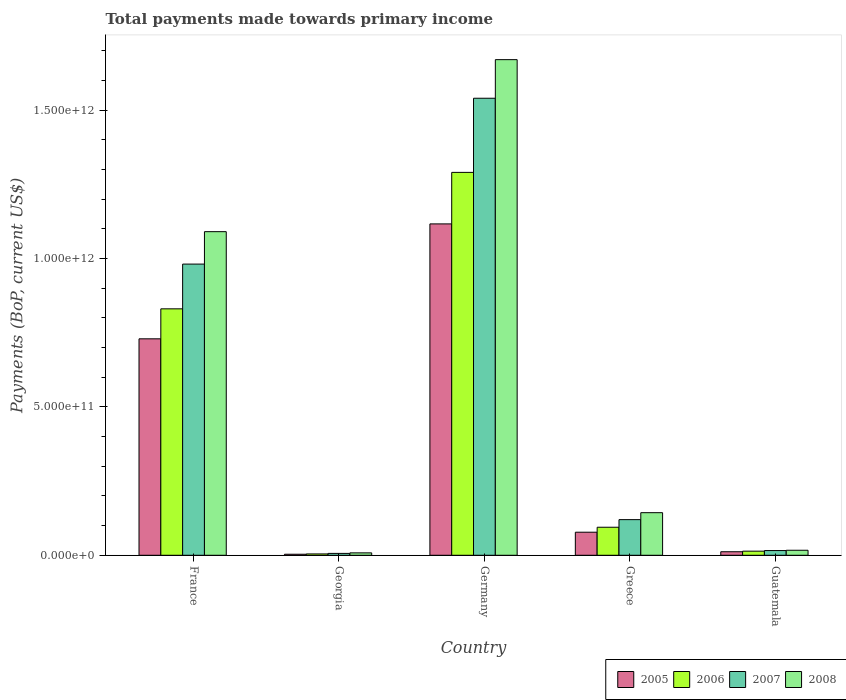How many different coloured bars are there?
Make the answer very short. 4. How many bars are there on the 3rd tick from the right?
Provide a succinct answer. 4. What is the label of the 3rd group of bars from the left?
Offer a very short reply. Germany. In how many cases, is the number of bars for a given country not equal to the number of legend labels?
Offer a very short reply. 0. What is the total payments made towards primary income in 2007 in Guatemala?
Provide a succinct answer. 1.59e+1. Across all countries, what is the maximum total payments made towards primary income in 2008?
Your answer should be compact. 1.67e+12. Across all countries, what is the minimum total payments made towards primary income in 2008?
Offer a terse response. 8.11e+09. In which country was the total payments made towards primary income in 2006 minimum?
Give a very brief answer. Georgia. What is the total total payments made towards primary income in 2006 in the graph?
Make the answer very short. 2.23e+12. What is the difference between the total payments made towards primary income in 2005 in France and that in Greece?
Provide a short and direct response. 6.52e+11. What is the difference between the total payments made towards primary income in 2005 in Georgia and the total payments made towards primary income in 2006 in Germany?
Ensure brevity in your answer.  -1.29e+12. What is the average total payments made towards primary income in 2005 per country?
Provide a short and direct response. 3.88e+11. What is the difference between the total payments made towards primary income of/in 2008 and total payments made towards primary income of/in 2005 in Germany?
Your answer should be compact. 5.53e+11. In how many countries, is the total payments made towards primary income in 2005 greater than 1300000000000 US$?
Your answer should be compact. 0. What is the ratio of the total payments made towards primary income in 2005 in Germany to that in Greece?
Your answer should be compact. 14.37. Is the difference between the total payments made towards primary income in 2008 in Georgia and Germany greater than the difference between the total payments made towards primary income in 2005 in Georgia and Germany?
Offer a very short reply. No. What is the difference between the highest and the second highest total payments made towards primary income in 2007?
Offer a terse response. 1.42e+12. What is the difference between the highest and the lowest total payments made towards primary income in 2007?
Give a very brief answer. 1.53e+12. What does the 2nd bar from the right in France represents?
Your answer should be very brief. 2007. How many bars are there?
Your answer should be compact. 20. How many countries are there in the graph?
Provide a succinct answer. 5. What is the difference between two consecutive major ticks on the Y-axis?
Your response must be concise. 5.00e+11. Does the graph contain any zero values?
Provide a short and direct response. No. How many legend labels are there?
Keep it short and to the point. 4. What is the title of the graph?
Your answer should be very brief. Total payments made towards primary income. What is the label or title of the Y-axis?
Ensure brevity in your answer.  Payments (BoP, current US$). What is the Payments (BoP, current US$) of 2005 in France?
Keep it short and to the point. 7.29e+11. What is the Payments (BoP, current US$) of 2006 in France?
Provide a succinct answer. 8.30e+11. What is the Payments (BoP, current US$) in 2007 in France?
Your answer should be very brief. 9.81e+11. What is the Payments (BoP, current US$) in 2008 in France?
Offer a very short reply. 1.09e+12. What is the Payments (BoP, current US$) of 2005 in Georgia?
Your response must be concise. 3.47e+09. What is the Payments (BoP, current US$) in 2006 in Georgia?
Your response must be concise. 4.56e+09. What is the Payments (BoP, current US$) of 2007 in Georgia?
Ensure brevity in your answer.  6.32e+09. What is the Payments (BoP, current US$) in 2008 in Georgia?
Your answer should be compact. 8.11e+09. What is the Payments (BoP, current US$) of 2005 in Germany?
Ensure brevity in your answer.  1.12e+12. What is the Payments (BoP, current US$) in 2006 in Germany?
Ensure brevity in your answer.  1.29e+12. What is the Payments (BoP, current US$) of 2007 in Germany?
Offer a very short reply. 1.54e+12. What is the Payments (BoP, current US$) in 2008 in Germany?
Provide a succinct answer. 1.67e+12. What is the Payments (BoP, current US$) of 2005 in Greece?
Offer a terse response. 7.77e+1. What is the Payments (BoP, current US$) of 2006 in Greece?
Keep it short and to the point. 9.44e+1. What is the Payments (BoP, current US$) in 2007 in Greece?
Provide a short and direct response. 1.20e+11. What is the Payments (BoP, current US$) in 2008 in Greece?
Your answer should be compact. 1.44e+11. What is the Payments (BoP, current US$) of 2005 in Guatemala?
Your response must be concise. 1.19e+1. What is the Payments (BoP, current US$) in 2006 in Guatemala?
Provide a short and direct response. 1.38e+1. What is the Payments (BoP, current US$) in 2007 in Guatemala?
Your answer should be very brief. 1.59e+1. What is the Payments (BoP, current US$) in 2008 in Guatemala?
Provide a short and direct response. 1.69e+1. Across all countries, what is the maximum Payments (BoP, current US$) of 2005?
Provide a succinct answer. 1.12e+12. Across all countries, what is the maximum Payments (BoP, current US$) in 2006?
Make the answer very short. 1.29e+12. Across all countries, what is the maximum Payments (BoP, current US$) in 2007?
Provide a succinct answer. 1.54e+12. Across all countries, what is the maximum Payments (BoP, current US$) in 2008?
Give a very brief answer. 1.67e+12. Across all countries, what is the minimum Payments (BoP, current US$) in 2005?
Keep it short and to the point. 3.47e+09. Across all countries, what is the minimum Payments (BoP, current US$) of 2006?
Ensure brevity in your answer.  4.56e+09. Across all countries, what is the minimum Payments (BoP, current US$) of 2007?
Keep it short and to the point. 6.32e+09. Across all countries, what is the minimum Payments (BoP, current US$) of 2008?
Provide a succinct answer. 8.11e+09. What is the total Payments (BoP, current US$) in 2005 in the graph?
Provide a succinct answer. 1.94e+12. What is the total Payments (BoP, current US$) of 2006 in the graph?
Make the answer very short. 2.23e+12. What is the total Payments (BoP, current US$) in 2007 in the graph?
Give a very brief answer. 2.66e+12. What is the total Payments (BoP, current US$) of 2008 in the graph?
Keep it short and to the point. 2.93e+12. What is the difference between the Payments (BoP, current US$) of 2005 in France and that in Georgia?
Your response must be concise. 7.26e+11. What is the difference between the Payments (BoP, current US$) in 2006 in France and that in Georgia?
Provide a short and direct response. 8.26e+11. What is the difference between the Payments (BoP, current US$) of 2007 in France and that in Georgia?
Your response must be concise. 9.75e+11. What is the difference between the Payments (BoP, current US$) in 2008 in France and that in Georgia?
Give a very brief answer. 1.08e+12. What is the difference between the Payments (BoP, current US$) in 2005 in France and that in Germany?
Your answer should be very brief. -3.87e+11. What is the difference between the Payments (BoP, current US$) in 2006 in France and that in Germany?
Your answer should be compact. -4.60e+11. What is the difference between the Payments (BoP, current US$) in 2007 in France and that in Germany?
Your answer should be compact. -5.59e+11. What is the difference between the Payments (BoP, current US$) in 2008 in France and that in Germany?
Your answer should be compact. -5.80e+11. What is the difference between the Payments (BoP, current US$) of 2005 in France and that in Greece?
Your answer should be very brief. 6.52e+11. What is the difference between the Payments (BoP, current US$) in 2006 in France and that in Greece?
Make the answer very short. 7.36e+11. What is the difference between the Payments (BoP, current US$) in 2007 in France and that in Greece?
Ensure brevity in your answer.  8.61e+11. What is the difference between the Payments (BoP, current US$) in 2008 in France and that in Greece?
Your answer should be compact. 9.47e+11. What is the difference between the Payments (BoP, current US$) in 2005 in France and that in Guatemala?
Provide a succinct answer. 7.17e+11. What is the difference between the Payments (BoP, current US$) in 2006 in France and that in Guatemala?
Offer a terse response. 8.17e+11. What is the difference between the Payments (BoP, current US$) of 2007 in France and that in Guatemala?
Ensure brevity in your answer.  9.65e+11. What is the difference between the Payments (BoP, current US$) in 2008 in France and that in Guatemala?
Your answer should be very brief. 1.07e+12. What is the difference between the Payments (BoP, current US$) of 2005 in Georgia and that in Germany?
Offer a terse response. -1.11e+12. What is the difference between the Payments (BoP, current US$) in 2006 in Georgia and that in Germany?
Keep it short and to the point. -1.29e+12. What is the difference between the Payments (BoP, current US$) in 2007 in Georgia and that in Germany?
Ensure brevity in your answer.  -1.53e+12. What is the difference between the Payments (BoP, current US$) of 2008 in Georgia and that in Germany?
Your answer should be compact. -1.66e+12. What is the difference between the Payments (BoP, current US$) of 2005 in Georgia and that in Greece?
Offer a terse response. -7.43e+1. What is the difference between the Payments (BoP, current US$) of 2006 in Georgia and that in Greece?
Provide a succinct answer. -8.99e+1. What is the difference between the Payments (BoP, current US$) in 2007 in Georgia and that in Greece?
Keep it short and to the point. -1.14e+11. What is the difference between the Payments (BoP, current US$) of 2008 in Georgia and that in Greece?
Your answer should be compact. -1.35e+11. What is the difference between the Payments (BoP, current US$) of 2005 in Georgia and that in Guatemala?
Provide a short and direct response. -8.42e+09. What is the difference between the Payments (BoP, current US$) in 2006 in Georgia and that in Guatemala?
Your answer should be very brief. -9.27e+09. What is the difference between the Payments (BoP, current US$) in 2007 in Georgia and that in Guatemala?
Offer a very short reply. -9.59e+09. What is the difference between the Payments (BoP, current US$) of 2008 in Georgia and that in Guatemala?
Your answer should be compact. -8.77e+09. What is the difference between the Payments (BoP, current US$) in 2005 in Germany and that in Greece?
Offer a very short reply. 1.04e+12. What is the difference between the Payments (BoP, current US$) in 2006 in Germany and that in Greece?
Keep it short and to the point. 1.20e+12. What is the difference between the Payments (BoP, current US$) in 2007 in Germany and that in Greece?
Offer a very short reply. 1.42e+12. What is the difference between the Payments (BoP, current US$) in 2008 in Germany and that in Greece?
Give a very brief answer. 1.53e+12. What is the difference between the Payments (BoP, current US$) of 2005 in Germany and that in Guatemala?
Make the answer very short. 1.10e+12. What is the difference between the Payments (BoP, current US$) in 2006 in Germany and that in Guatemala?
Make the answer very short. 1.28e+12. What is the difference between the Payments (BoP, current US$) in 2007 in Germany and that in Guatemala?
Your answer should be compact. 1.52e+12. What is the difference between the Payments (BoP, current US$) of 2008 in Germany and that in Guatemala?
Make the answer very short. 1.65e+12. What is the difference between the Payments (BoP, current US$) of 2005 in Greece and that in Guatemala?
Give a very brief answer. 6.58e+1. What is the difference between the Payments (BoP, current US$) in 2006 in Greece and that in Guatemala?
Provide a short and direct response. 8.06e+1. What is the difference between the Payments (BoP, current US$) of 2007 in Greece and that in Guatemala?
Provide a short and direct response. 1.04e+11. What is the difference between the Payments (BoP, current US$) in 2008 in Greece and that in Guatemala?
Provide a short and direct response. 1.27e+11. What is the difference between the Payments (BoP, current US$) in 2005 in France and the Payments (BoP, current US$) in 2006 in Georgia?
Keep it short and to the point. 7.25e+11. What is the difference between the Payments (BoP, current US$) in 2005 in France and the Payments (BoP, current US$) in 2007 in Georgia?
Give a very brief answer. 7.23e+11. What is the difference between the Payments (BoP, current US$) of 2005 in France and the Payments (BoP, current US$) of 2008 in Georgia?
Offer a terse response. 7.21e+11. What is the difference between the Payments (BoP, current US$) in 2006 in France and the Payments (BoP, current US$) in 2007 in Georgia?
Offer a terse response. 8.24e+11. What is the difference between the Payments (BoP, current US$) of 2006 in France and the Payments (BoP, current US$) of 2008 in Georgia?
Offer a very short reply. 8.22e+11. What is the difference between the Payments (BoP, current US$) of 2007 in France and the Payments (BoP, current US$) of 2008 in Georgia?
Your response must be concise. 9.73e+11. What is the difference between the Payments (BoP, current US$) in 2005 in France and the Payments (BoP, current US$) in 2006 in Germany?
Ensure brevity in your answer.  -5.61e+11. What is the difference between the Payments (BoP, current US$) in 2005 in France and the Payments (BoP, current US$) in 2007 in Germany?
Provide a succinct answer. -8.11e+11. What is the difference between the Payments (BoP, current US$) of 2005 in France and the Payments (BoP, current US$) of 2008 in Germany?
Your answer should be very brief. -9.41e+11. What is the difference between the Payments (BoP, current US$) of 2006 in France and the Payments (BoP, current US$) of 2007 in Germany?
Your answer should be very brief. -7.10e+11. What is the difference between the Payments (BoP, current US$) in 2006 in France and the Payments (BoP, current US$) in 2008 in Germany?
Offer a very short reply. -8.40e+11. What is the difference between the Payments (BoP, current US$) of 2007 in France and the Payments (BoP, current US$) of 2008 in Germany?
Your answer should be compact. -6.89e+11. What is the difference between the Payments (BoP, current US$) of 2005 in France and the Payments (BoP, current US$) of 2006 in Greece?
Your answer should be very brief. 6.35e+11. What is the difference between the Payments (BoP, current US$) in 2005 in France and the Payments (BoP, current US$) in 2007 in Greece?
Your answer should be compact. 6.09e+11. What is the difference between the Payments (BoP, current US$) of 2005 in France and the Payments (BoP, current US$) of 2008 in Greece?
Your response must be concise. 5.86e+11. What is the difference between the Payments (BoP, current US$) in 2006 in France and the Payments (BoP, current US$) in 2007 in Greece?
Make the answer very short. 7.10e+11. What is the difference between the Payments (BoP, current US$) of 2006 in France and the Payments (BoP, current US$) of 2008 in Greece?
Your response must be concise. 6.87e+11. What is the difference between the Payments (BoP, current US$) of 2007 in France and the Payments (BoP, current US$) of 2008 in Greece?
Your response must be concise. 8.38e+11. What is the difference between the Payments (BoP, current US$) of 2005 in France and the Payments (BoP, current US$) of 2006 in Guatemala?
Provide a short and direct response. 7.15e+11. What is the difference between the Payments (BoP, current US$) in 2005 in France and the Payments (BoP, current US$) in 2007 in Guatemala?
Provide a short and direct response. 7.13e+11. What is the difference between the Payments (BoP, current US$) in 2005 in France and the Payments (BoP, current US$) in 2008 in Guatemala?
Provide a succinct answer. 7.12e+11. What is the difference between the Payments (BoP, current US$) of 2006 in France and the Payments (BoP, current US$) of 2007 in Guatemala?
Give a very brief answer. 8.14e+11. What is the difference between the Payments (BoP, current US$) in 2006 in France and the Payments (BoP, current US$) in 2008 in Guatemala?
Offer a very short reply. 8.13e+11. What is the difference between the Payments (BoP, current US$) in 2007 in France and the Payments (BoP, current US$) in 2008 in Guatemala?
Make the answer very short. 9.64e+11. What is the difference between the Payments (BoP, current US$) in 2005 in Georgia and the Payments (BoP, current US$) in 2006 in Germany?
Your response must be concise. -1.29e+12. What is the difference between the Payments (BoP, current US$) of 2005 in Georgia and the Payments (BoP, current US$) of 2007 in Germany?
Ensure brevity in your answer.  -1.54e+12. What is the difference between the Payments (BoP, current US$) of 2005 in Georgia and the Payments (BoP, current US$) of 2008 in Germany?
Keep it short and to the point. -1.67e+12. What is the difference between the Payments (BoP, current US$) of 2006 in Georgia and the Payments (BoP, current US$) of 2007 in Germany?
Make the answer very short. -1.54e+12. What is the difference between the Payments (BoP, current US$) in 2006 in Georgia and the Payments (BoP, current US$) in 2008 in Germany?
Provide a short and direct response. -1.67e+12. What is the difference between the Payments (BoP, current US$) of 2007 in Georgia and the Payments (BoP, current US$) of 2008 in Germany?
Your response must be concise. -1.66e+12. What is the difference between the Payments (BoP, current US$) of 2005 in Georgia and the Payments (BoP, current US$) of 2006 in Greece?
Your answer should be very brief. -9.10e+1. What is the difference between the Payments (BoP, current US$) of 2005 in Georgia and the Payments (BoP, current US$) of 2007 in Greece?
Your response must be concise. -1.17e+11. What is the difference between the Payments (BoP, current US$) of 2005 in Georgia and the Payments (BoP, current US$) of 2008 in Greece?
Offer a terse response. -1.40e+11. What is the difference between the Payments (BoP, current US$) of 2006 in Georgia and the Payments (BoP, current US$) of 2007 in Greece?
Make the answer very short. -1.16e+11. What is the difference between the Payments (BoP, current US$) in 2006 in Georgia and the Payments (BoP, current US$) in 2008 in Greece?
Your answer should be compact. -1.39e+11. What is the difference between the Payments (BoP, current US$) of 2007 in Georgia and the Payments (BoP, current US$) of 2008 in Greece?
Provide a succinct answer. -1.37e+11. What is the difference between the Payments (BoP, current US$) in 2005 in Georgia and the Payments (BoP, current US$) in 2006 in Guatemala?
Provide a succinct answer. -1.04e+1. What is the difference between the Payments (BoP, current US$) of 2005 in Georgia and the Payments (BoP, current US$) of 2007 in Guatemala?
Provide a short and direct response. -1.24e+1. What is the difference between the Payments (BoP, current US$) in 2005 in Georgia and the Payments (BoP, current US$) in 2008 in Guatemala?
Make the answer very short. -1.34e+1. What is the difference between the Payments (BoP, current US$) of 2006 in Georgia and the Payments (BoP, current US$) of 2007 in Guatemala?
Provide a short and direct response. -1.14e+1. What is the difference between the Payments (BoP, current US$) in 2006 in Georgia and the Payments (BoP, current US$) in 2008 in Guatemala?
Your answer should be very brief. -1.23e+1. What is the difference between the Payments (BoP, current US$) in 2007 in Georgia and the Payments (BoP, current US$) in 2008 in Guatemala?
Keep it short and to the point. -1.06e+1. What is the difference between the Payments (BoP, current US$) of 2005 in Germany and the Payments (BoP, current US$) of 2006 in Greece?
Provide a succinct answer. 1.02e+12. What is the difference between the Payments (BoP, current US$) of 2005 in Germany and the Payments (BoP, current US$) of 2007 in Greece?
Provide a short and direct response. 9.96e+11. What is the difference between the Payments (BoP, current US$) of 2005 in Germany and the Payments (BoP, current US$) of 2008 in Greece?
Provide a short and direct response. 9.73e+11. What is the difference between the Payments (BoP, current US$) in 2006 in Germany and the Payments (BoP, current US$) in 2007 in Greece?
Your response must be concise. 1.17e+12. What is the difference between the Payments (BoP, current US$) of 2006 in Germany and the Payments (BoP, current US$) of 2008 in Greece?
Provide a succinct answer. 1.15e+12. What is the difference between the Payments (BoP, current US$) in 2007 in Germany and the Payments (BoP, current US$) in 2008 in Greece?
Keep it short and to the point. 1.40e+12. What is the difference between the Payments (BoP, current US$) in 2005 in Germany and the Payments (BoP, current US$) in 2006 in Guatemala?
Your response must be concise. 1.10e+12. What is the difference between the Payments (BoP, current US$) of 2005 in Germany and the Payments (BoP, current US$) of 2007 in Guatemala?
Your response must be concise. 1.10e+12. What is the difference between the Payments (BoP, current US$) in 2005 in Germany and the Payments (BoP, current US$) in 2008 in Guatemala?
Keep it short and to the point. 1.10e+12. What is the difference between the Payments (BoP, current US$) of 2006 in Germany and the Payments (BoP, current US$) of 2007 in Guatemala?
Make the answer very short. 1.27e+12. What is the difference between the Payments (BoP, current US$) in 2006 in Germany and the Payments (BoP, current US$) in 2008 in Guatemala?
Ensure brevity in your answer.  1.27e+12. What is the difference between the Payments (BoP, current US$) in 2007 in Germany and the Payments (BoP, current US$) in 2008 in Guatemala?
Keep it short and to the point. 1.52e+12. What is the difference between the Payments (BoP, current US$) in 2005 in Greece and the Payments (BoP, current US$) in 2006 in Guatemala?
Keep it short and to the point. 6.39e+1. What is the difference between the Payments (BoP, current US$) of 2005 in Greece and the Payments (BoP, current US$) of 2007 in Guatemala?
Provide a succinct answer. 6.18e+1. What is the difference between the Payments (BoP, current US$) in 2005 in Greece and the Payments (BoP, current US$) in 2008 in Guatemala?
Provide a short and direct response. 6.08e+1. What is the difference between the Payments (BoP, current US$) in 2006 in Greece and the Payments (BoP, current US$) in 2007 in Guatemala?
Provide a succinct answer. 7.85e+1. What is the difference between the Payments (BoP, current US$) in 2006 in Greece and the Payments (BoP, current US$) in 2008 in Guatemala?
Ensure brevity in your answer.  7.76e+1. What is the difference between the Payments (BoP, current US$) of 2007 in Greece and the Payments (BoP, current US$) of 2008 in Guatemala?
Provide a succinct answer. 1.03e+11. What is the average Payments (BoP, current US$) of 2005 per country?
Give a very brief answer. 3.88e+11. What is the average Payments (BoP, current US$) of 2006 per country?
Offer a terse response. 4.47e+11. What is the average Payments (BoP, current US$) of 2007 per country?
Give a very brief answer. 5.33e+11. What is the average Payments (BoP, current US$) of 2008 per country?
Offer a terse response. 5.86e+11. What is the difference between the Payments (BoP, current US$) of 2005 and Payments (BoP, current US$) of 2006 in France?
Your answer should be compact. -1.01e+11. What is the difference between the Payments (BoP, current US$) of 2005 and Payments (BoP, current US$) of 2007 in France?
Your answer should be very brief. -2.52e+11. What is the difference between the Payments (BoP, current US$) in 2005 and Payments (BoP, current US$) in 2008 in France?
Provide a succinct answer. -3.61e+11. What is the difference between the Payments (BoP, current US$) in 2006 and Payments (BoP, current US$) in 2007 in France?
Make the answer very short. -1.51e+11. What is the difference between the Payments (BoP, current US$) in 2006 and Payments (BoP, current US$) in 2008 in France?
Provide a succinct answer. -2.60e+11. What is the difference between the Payments (BoP, current US$) of 2007 and Payments (BoP, current US$) of 2008 in France?
Your answer should be very brief. -1.09e+11. What is the difference between the Payments (BoP, current US$) in 2005 and Payments (BoP, current US$) in 2006 in Georgia?
Your answer should be very brief. -1.09e+09. What is the difference between the Payments (BoP, current US$) in 2005 and Payments (BoP, current US$) in 2007 in Georgia?
Your answer should be very brief. -2.86e+09. What is the difference between the Payments (BoP, current US$) in 2005 and Payments (BoP, current US$) in 2008 in Georgia?
Ensure brevity in your answer.  -4.65e+09. What is the difference between the Payments (BoP, current US$) in 2006 and Payments (BoP, current US$) in 2007 in Georgia?
Ensure brevity in your answer.  -1.77e+09. What is the difference between the Payments (BoP, current US$) of 2006 and Payments (BoP, current US$) of 2008 in Georgia?
Provide a short and direct response. -3.56e+09. What is the difference between the Payments (BoP, current US$) of 2007 and Payments (BoP, current US$) of 2008 in Georgia?
Provide a short and direct response. -1.79e+09. What is the difference between the Payments (BoP, current US$) of 2005 and Payments (BoP, current US$) of 2006 in Germany?
Offer a terse response. -1.74e+11. What is the difference between the Payments (BoP, current US$) in 2005 and Payments (BoP, current US$) in 2007 in Germany?
Keep it short and to the point. -4.23e+11. What is the difference between the Payments (BoP, current US$) of 2005 and Payments (BoP, current US$) of 2008 in Germany?
Offer a very short reply. -5.53e+11. What is the difference between the Payments (BoP, current US$) of 2006 and Payments (BoP, current US$) of 2007 in Germany?
Provide a short and direct response. -2.50e+11. What is the difference between the Payments (BoP, current US$) in 2006 and Payments (BoP, current US$) in 2008 in Germany?
Offer a terse response. -3.80e+11. What is the difference between the Payments (BoP, current US$) of 2007 and Payments (BoP, current US$) of 2008 in Germany?
Your response must be concise. -1.30e+11. What is the difference between the Payments (BoP, current US$) of 2005 and Payments (BoP, current US$) of 2006 in Greece?
Offer a very short reply. -1.67e+1. What is the difference between the Payments (BoP, current US$) in 2005 and Payments (BoP, current US$) in 2007 in Greece?
Keep it short and to the point. -4.24e+1. What is the difference between the Payments (BoP, current US$) in 2005 and Payments (BoP, current US$) in 2008 in Greece?
Make the answer very short. -6.58e+1. What is the difference between the Payments (BoP, current US$) of 2006 and Payments (BoP, current US$) of 2007 in Greece?
Provide a succinct answer. -2.56e+1. What is the difference between the Payments (BoP, current US$) of 2006 and Payments (BoP, current US$) of 2008 in Greece?
Give a very brief answer. -4.91e+1. What is the difference between the Payments (BoP, current US$) of 2007 and Payments (BoP, current US$) of 2008 in Greece?
Your response must be concise. -2.34e+1. What is the difference between the Payments (BoP, current US$) of 2005 and Payments (BoP, current US$) of 2006 in Guatemala?
Offer a very short reply. -1.94e+09. What is the difference between the Payments (BoP, current US$) in 2005 and Payments (BoP, current US$) in 2007 in Guatemala?
Your answer should be very brief. -4.02e+09. What is the difference between the Payments (BoP, current US$) of 2005 and Payments (BoP, current US$) of 2008 in Guatemala?
Your answer should be very brief. -5.00e+09. What is the difference between the Payments (BoP, current US$) in 2006 and Payments (BoP, current US$) in 2007 in Guatemala?
Provide a succinct answer. -2.08e+09. What is the difference between the Payments (BoP, current US$) in 2006 and Payments (BoP, current US$) in 2008 in Guatemala?
Offer a very short reply. -3.06e+09. What is the difference between the Payments (BoP, current US$) of 2007 and Payments (BoP, current US$) of 2008 in Guatemala?
Keep it short and to the point. -9.78e+08. What is the ratio of the Payments (BoP, current US$) of 2005 in France to that in Georgia?
Your answer should be very brief. 210.24. What is the ratio of the Payments (BoP, current US$) of 2006 in France to that in Georgia?
Offer a very short reply. 182.27. What is the ratio of the Payments (BoP, current US$) of 2007 in France to that in Georgia?
Your answer should be very brief. 155.13. What is the ratio of the Payments (BoP, current US$) in 2008 in France to that in Georgia?
Offer a terse response. 134.37. What is the ratio of the Payments (BoP, current US$) of 2005 in France to that in Germany?
Offer a terse response. 0.65. What is the ratio of the Payments (BoP, current US$) in 2006 in France to that in Germany?
Offer a terse response. 0.64. What is the ratio of the Payments (BoP, current US$) of 2007 in France to that in Germany?
Ensure brevity in your answer.  0.64. What is the ratio of the Payments (BoP, current US$) of 2008 in France to that in Germany?
Provide a short and direct response. 0.65. What is the ratio of the Payments (BoP, current US$) of 2005 in France to that in Greece?
Ensure brevity in your answer.  9.38. What is the ratio of the Payments (BoP, current US$) in 2006 in France to that in Greece?
Offer a very short reply. 8.79. What is the ratio of the Payments (BoP, current US$) in 2007 in France to that in Greece?
Give a very brief answer. 8.17. What is the ratio of the Payments (BoP, current US$) in 2008 in France to that in Greece?
Provide a short and direct response. 7.6. What is the ratio of the Payments (BoP, current US$) of 2005 in France to that in Guatemala?
Your response must be concise. 61.36. What is the ratio of the Payments (BoP, current US$) of 2006 in France to that in Guatemala?
Provide a short and direct response. 60.05. What is the ratio of the Payments (BoP, current US$) in 2007 in France to that in Guatemala?
Provide a short and direct response. 61.67. What is the ratio of the Payments (BoP, current US$) of 2008 in France to that in Guatemala?
Provide a short and direct response. 64.56. What is the ratio of the Payments (BoP, current US$) of 2005 in Georgia to that in Germany?
Provide a succinct answer. 0. What is the ratio of the Payments (BoP, current US$) in 2006 in Georgia to that in Germany?
Offer a terse response. 0. What is the ratio of the Payments (BoP, current US$) of 2007 in Georgia to that in Germany?
Provide a succinct answer. 0. What is the ratio of the Payments (BoP, current US$) of 2008 in Georgia to that in Germany?
Give a very brief answer. 0. What is the ratio of the Payments (BoP, current US$) in 2005 in Georgia to that in Greece?
Offer a terse response. 0.04. What is the ratio of the Payments (BoP, current US$) of 2006 in Georgia to that in Greece?
Offer a terse response. 0.05. What is the ratio of the Payments (BoP, current US$) in 2007 in Georgia to that in Greece?
Keep it short and to the point. 0.05. What is the ratio of the Payments (BoP, current US$) in 2008 in Georgia to that in Greece?
Provide a succinct answer. 0.06. What is the ratio of the Payments (BoP, current US$) of 2005 in Georgia to that in Guatemala?
Offer a terse response. 0.29. What is the ratio of the Payments (BoP, current US$) of 2006 in Georgia to that in Guatemala?
Offer a terse response. 0.33. What is the ratio of the Payments (BoP, current US$) of 2007 in Georgia to that in Guatemala?
Provide a short and direct response. 0.4. What is the ratio of the Payments (BoP, current US$) of 2008 in Georgia to that in Guatemala?
Your answer should be very brief. 0.48. What is the ratio of the Payments (BoP, current US$) of 2005 in Germany to that in Greece?
Make the answer very short. 14.37. What is the ratio of the Payments (BoP, current US$) in 2006 in Germany to that in Greece?
Keep it short and to the point. 13.66. What is the ratio of the Payments (BoP, current US$) in 2007 in Germany to that in Greece?
Offer a terse response. 12.82. What is the ratio of the Payments (BoP, current US$) of 2008 in Germany to that in Greece?
Keep it short and to the point. 11.64. What is the ratio of the Payments (BoP, current US$) of 2005 in Germany to that in Guatemala?
Offer a terse response. 93.94. What is the ratio of the Payments (BoP, current US$) in 2006 in Germany to that in Guatemala?
Your answer should be very brief. 93.3. What is the ratio of the Payments (BoP, current US$) in 2007 in Germany to that in Guatemala?
Make the answer very short. 96.79. What is the ratio of the Payments (BoP, current US$) of 2008 in Germany to that in Guatemala?
Ensure brevity in your answer.  98.88. What is the ratio of the Payments (BoP, current US$) of 2005 in Greece to that in Guatemala?
Offer a very short reply. 6.54. What is the ratio of the Payments (BoP, current US$) of 2006 in Greece to that in Guatemala?
Provide a succinct answer. 6.83. What is the ratio of the Payments (BoP, current US$) in 2007 in Greece to that in Guatemala?
Offer a very short reply. 7.55. What is the ratio of the Payments (BoP, current US$) in 2008 in Greece to that in Guatemala?
Offer a terse response. 8.5. What is the difference between the highest and the second highest Payments (BoP, current US$) in 2005?
Provide a short and direct response. 3.87e+11. What is the difference between the highest and the second highest Payments (BoP, current US$) in 2006?
Make the answer very short. 4.60e+11. What is the difference between the highest and the second highest Payments (BoP, current US$) of 2007?
Provide a short and direct response. 5.59e+11. What is the difference between the highest and the second highest Payments (BoP, current US$) in 2008?
Keep it short and to the point. 5.80e+11. What is the difference between the highest and the lowest Payments (BoP, current US$) in 2005?
Your answer should be very brief. 1.11e+12. What is the difference between the highest and the lowest Payments (BoP, current US$) in 2006?
Provide a succinct answer. 1.29e+12. What is the difference between the highest and the lowest Payments (BoP, current US$) in 2007?
Make the answer very short. 1.53e+12. What is the difference between the highest and the lowest Payments (BoP, current US$) in 2008?
Your answer should be very brief. 1.66e+12. 